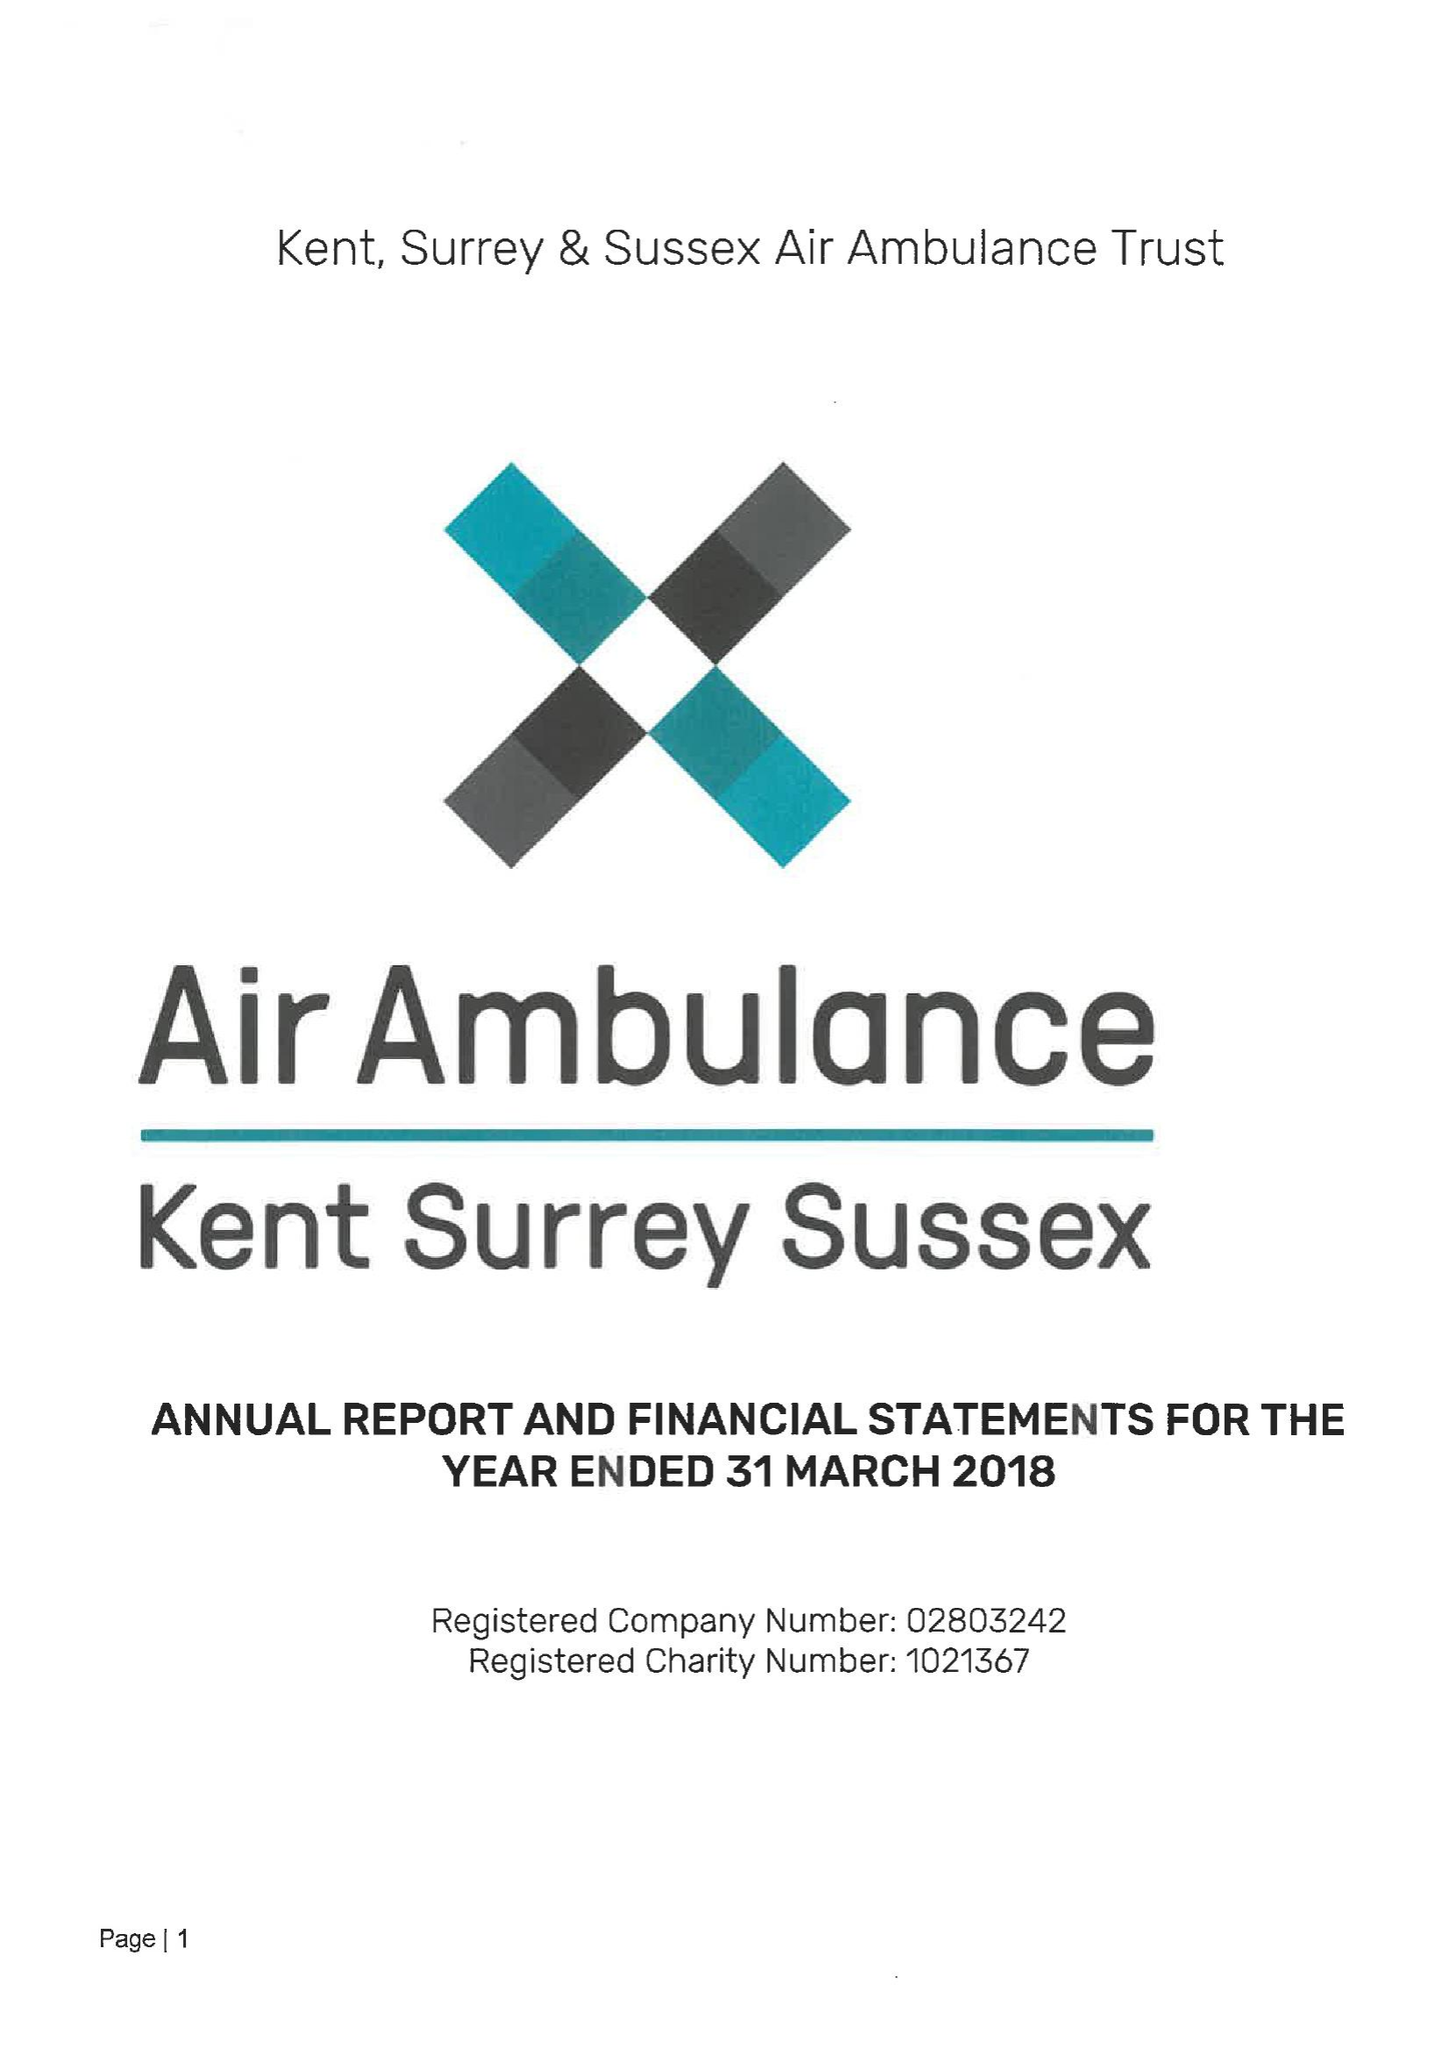What is the value for the report_date?
Answer the question using a single word or phrase. 2018-03-31 